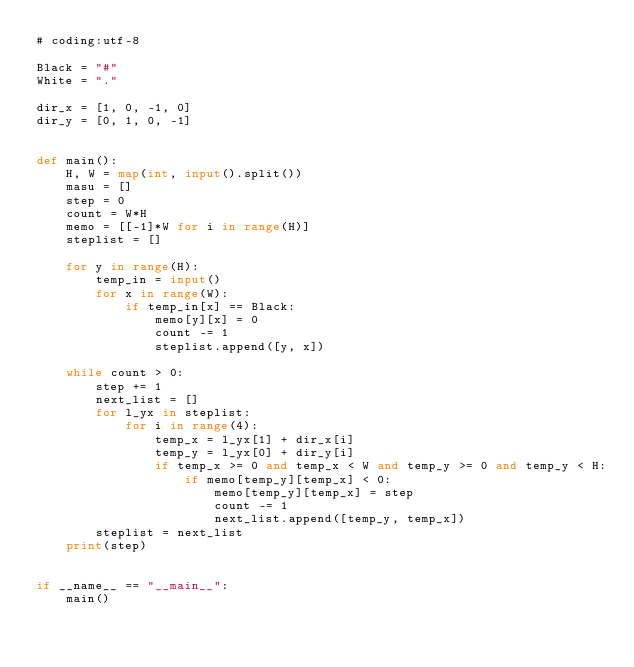<code> <loc_0><loc_0><loc_500><loc_500><_Python_># coding:utf-8

Black = "#"
White = "."

dir_x = [1, 0, -1, 0]
dir_y = [0, 1, 0, -1]


def main():
    H, W = map(int, input().split())
    masu = []
    step = 0
    count = W*H
    memo = [[-1]*W for i in range(H)]
    steplist = []

    for y in range(H):
        temp_in = input()
        for x in range(W):
            if temp_in[x] == Black:
                memo[y][x] = 0
                count -= 1
                steplist.append([y, x])

    while count > 0:
        step += 1
        next_list = []
        for l_yx in steplist:
            for i in range(4):
                temp_x = l_yx[1] + dir_x[i]
                temp_y = l_yx[0] + dir_y[i]
                if temp_x >= 0 and temp_x < W and temp_y >= 0 and temp_y < H:
                    if memo[temp_y][temp_x] < 0:
                        memo[temp_y][temp_x] = step
                        count -= 1
                        next_list.append([temp_y, temp_x])
        steplist = next_list
    print(step)


if __name__ == "__main__":
    main()
</code> 